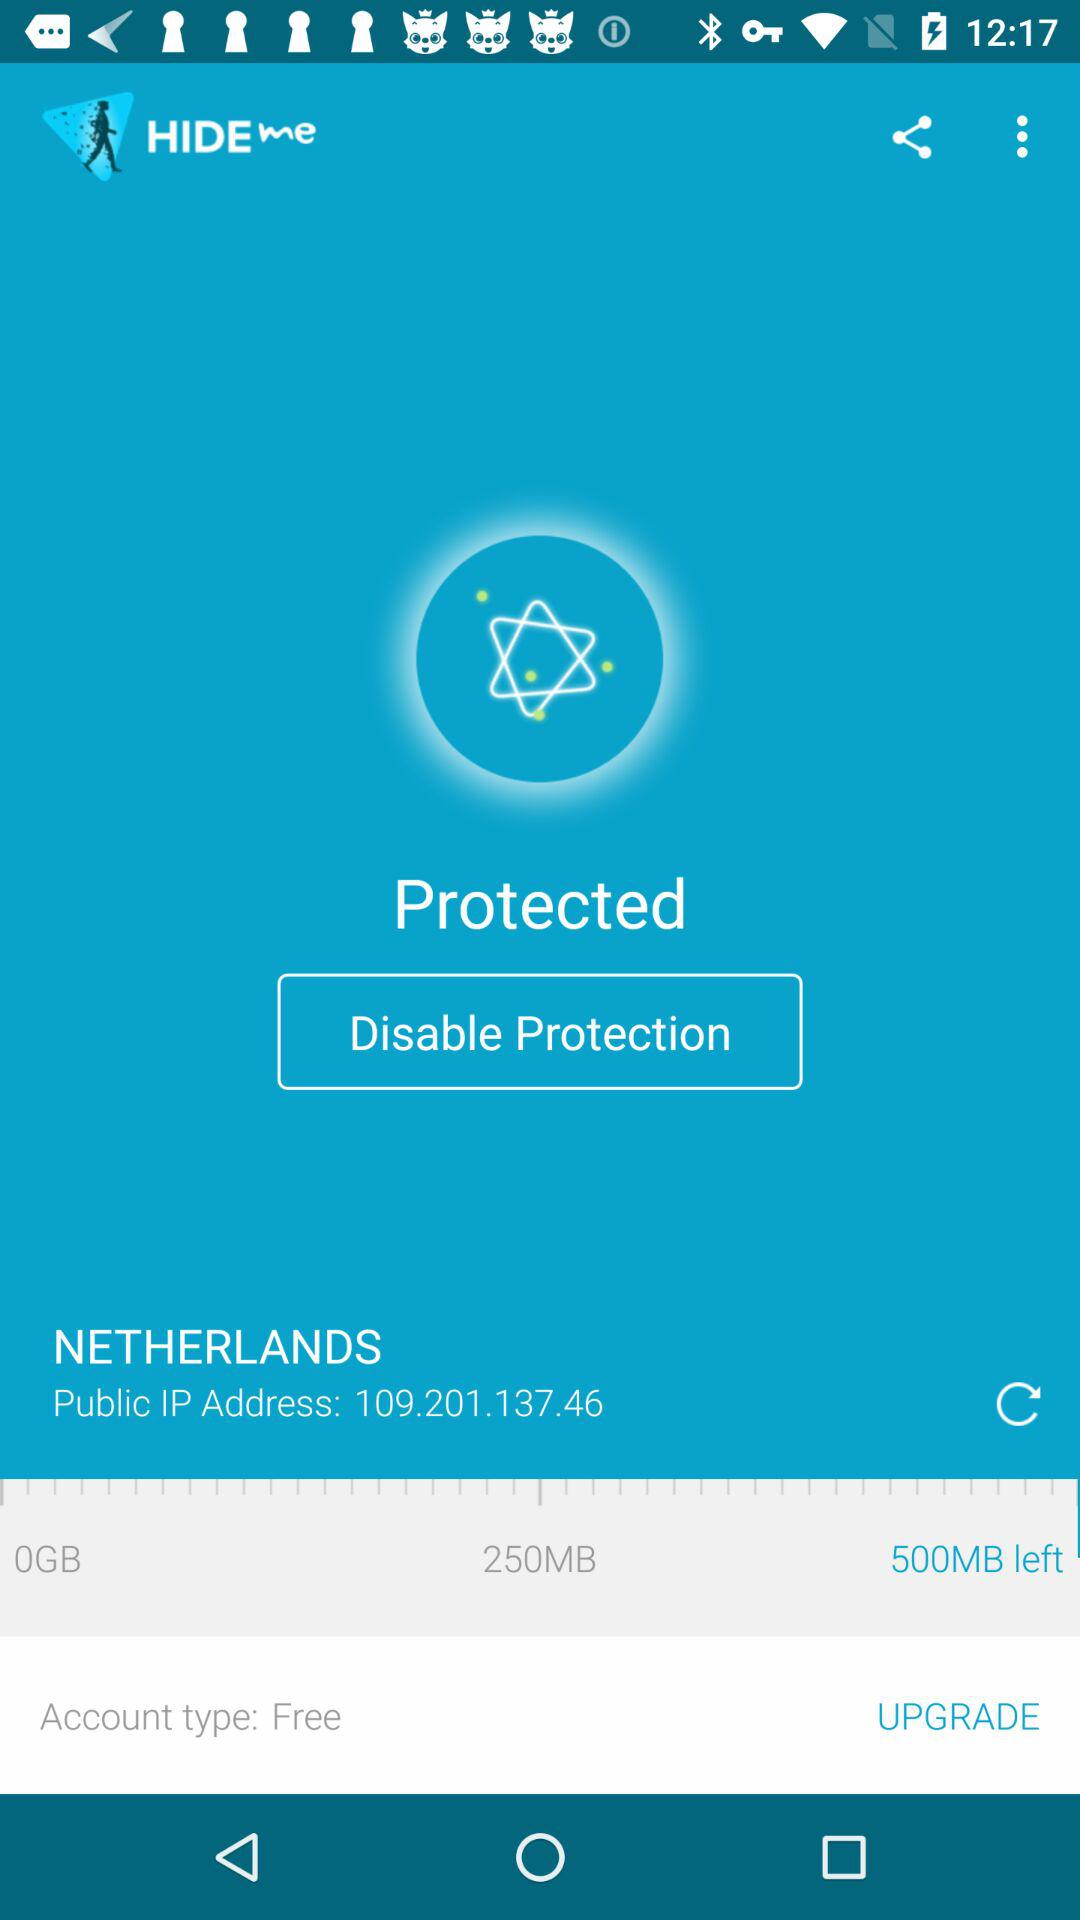How much data do I have left before I need to upgrade?
Answer the question using a single word or phrase. 500MB 